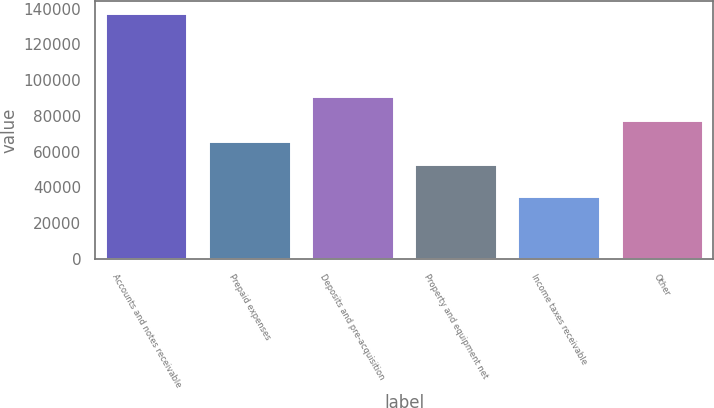Convert chart. <chart><loc_0><loc_0><loc_500><loc_500><bar_chart><fcel>Accounts and notes receivable<fcel>Prepaid expenses<fcel>Deposits and pre-acquisition<fcel>Property and equipment net<fcel>Income taxes receivable<fcel>Other<nl><fcel>137428<fcel>65965<fcel>91034<fcel>53051<fcel>35437<fcel>77706<nl></chart> 